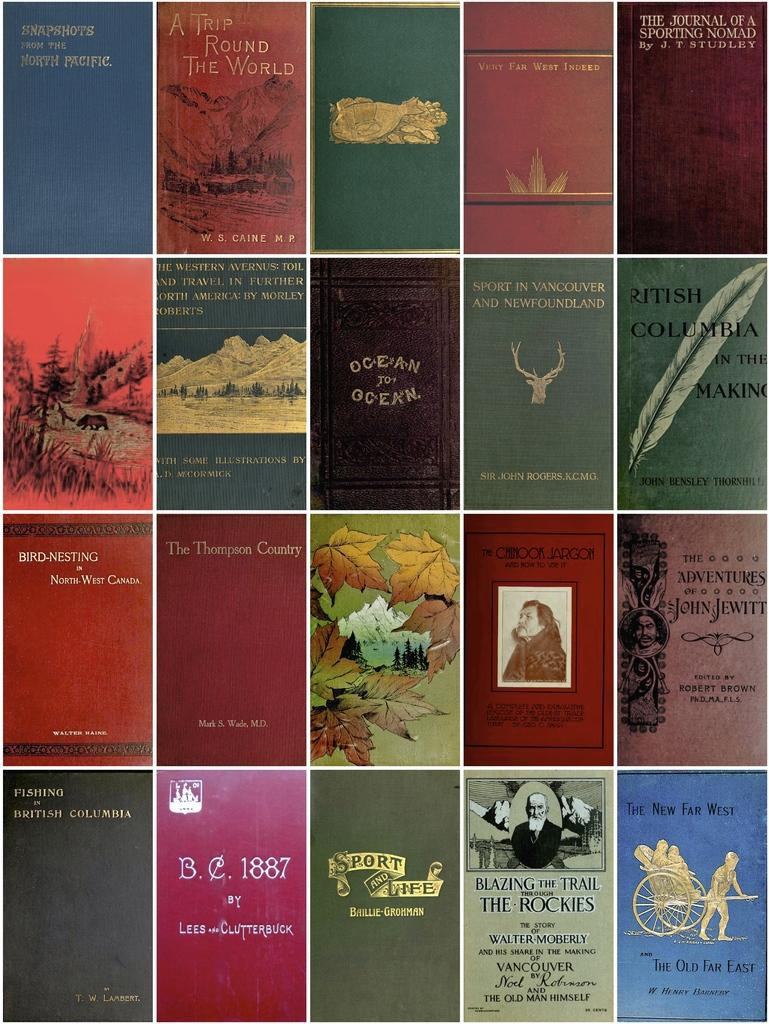<image>
Offer a succinct explanation of the picture presented. A colorful collection of book covers with one of them titled Snapshots from the North Pacific. 